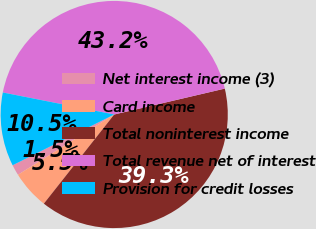Convert chart. <chart><loc_0><loc_0><loc_500><loc_500><pie_chart><fcel>Net interest income (3)<fcel>Card income<fcel>Total noninterest income<fcel>Total revenue net of interest<fcel>Provision for credit losses<nl><fcel>1.53%<fcel>5.46%<fcel>39.29%<fcel>43.22%<fcel>10.48%<nl></chart> 